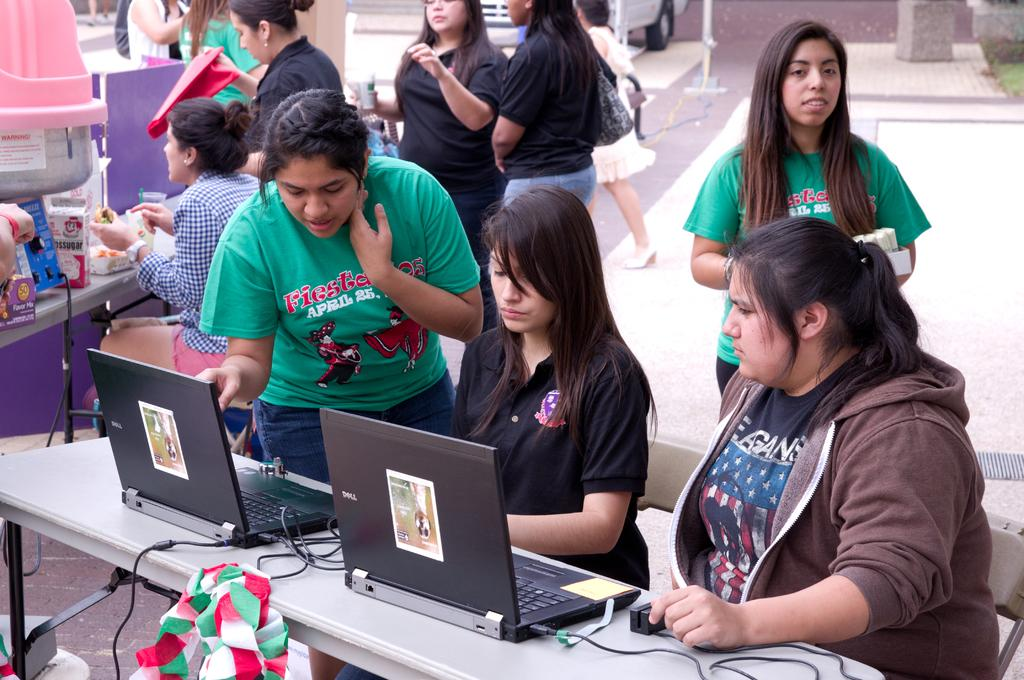<image>
Offer a succinct explanation of the picture presented. People are around tables, some wearing shirts that say Fiesta. 